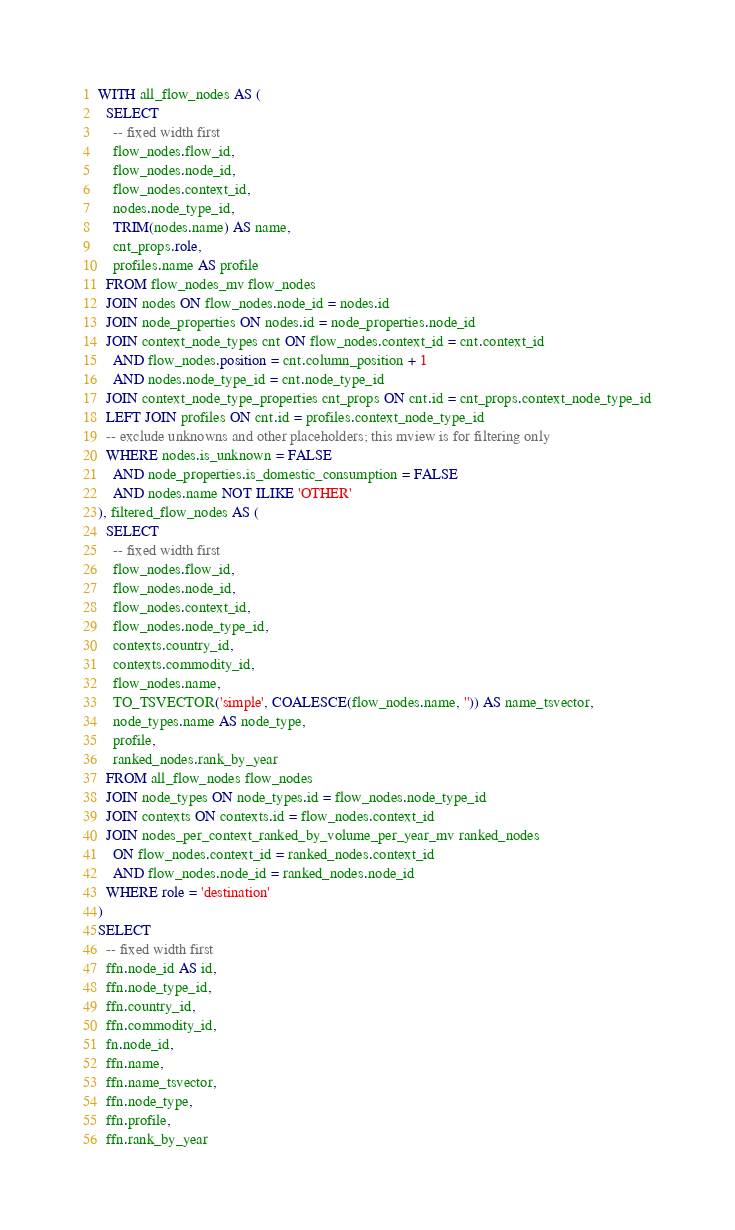<code> <loc_0><loc_0><loc_500><loc_500><_SQL_>WITH all_flow_nodes AS (
  SELECT
    -- fixed width first
    flow_nodes.flow_id,
    flow_nodes.node_id,
    flow_nodes.context_id,
    nodes.node_type_id,
    TRIM(nodes.name) AS name,
    cnt_props.role,
    profiles.name AS profile
  FROM flow_nodes_mv flow_nodes
  JOIN nodes ON flow_nodes.node_id = nodes.id
  JOIN node_properties ON nodes.id = node_properties.node_id
  JOIN context_node_types cnt ON flow_nodes.context_id = cnt.context_id
    AND flow_nodes.position = cnt.column_position + 1
    AND nodes.node_type_id = cnt.node_type_id
  JOIN context_node_type_properties cnt_props ON cnt.id = cnt_props.context_node_type_id
  LEFT JOIN profiles ON cnt.id = profiles.context_node_type_id
  -- exclude unknowns and other placeholders; this mview is for filtering only
  WHERE nodes.is_unknown = FALSE
    AND node_properties.is_domestic_consumption = FALSE
    AND nodes.name NOT ILIKE 'OTHER'
), filtered_flow_nodes AS (
  SELECT
    -- fixed width first
    flow_nodes.flow_id,
    flow_nodes.node_id,
    flow_nodes.context_id,
    flow_nodes.node_type_id,
    contexts.country_id,
    contexts.commodity_id,
    flow_nodes.name,
    TO_TSVECTOR('simple', COALESCE(flow_nodes.name, '')) AS name_tsvector,
    node_types.name AS node_type,
    profile,
    ranked_nodes.rank_by_year
  FROM all_flow_nodes flow_nodes
  JOIN node_types ON node_types.id = flow_nodes.node_type_id
  JOIN contexts ON contexts.id = flow_nodes.context_id
  JOIN nodes_per_context_ranked_by_volume_per_year_mv ranked_nodes
    ON flow_nodes.context_id = ranked_nodes.context_id
    AND flow_nodes.node_id = ranked_nodes.node_id
  WHERE role = 'destination'
)
SELECT
  -- fixed width first
  ffn.node_id AS id,
  ffn.node_type_id,
  ffn.country_id,
  ffn.commodity_id,
  fn.node_id,
  ffn.name,
  ffn.name_tsvector,
  ffn.node_type,
  ffn.profile,
  ffn.rank_by_year</code> 